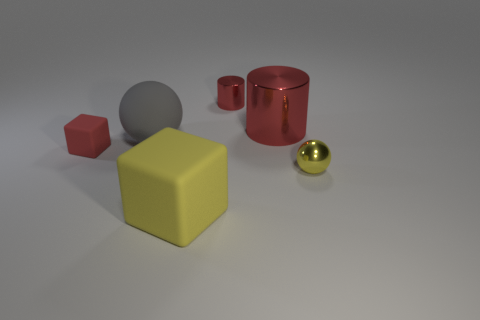Add 1 small yellow cylinders. How many objects exist? 7 Subtract all blocks. How many objects are left? 4 Add 4 tiny brown balls. How many tiny brown balls exist? 4 Subtract 0 gray blocks. How many objects are left? 6 Subtract all tiny purple things. Subtract all small red objects. How many objects are left? 4 Add 6 big yellow matte blocks. How many big yellow matte blocks are left? 7 